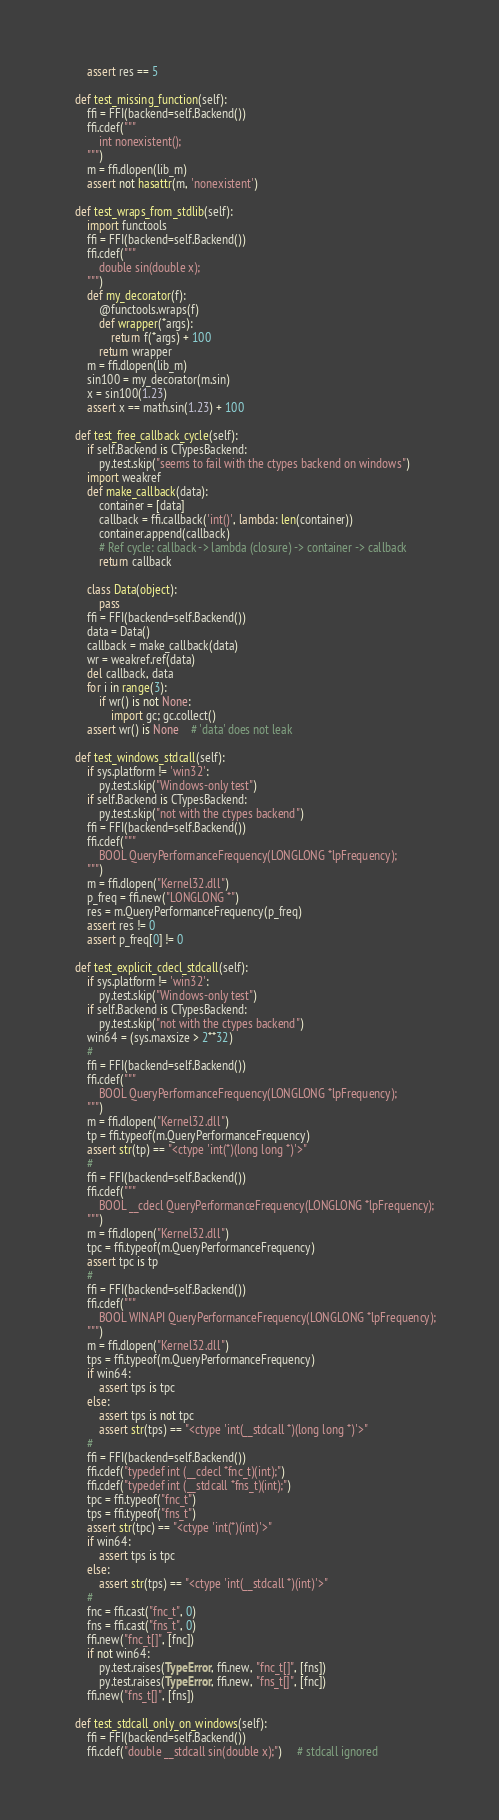<code> <loc_0><loc_0><loc_500><loc_500><_Python_>        assert res == 5

    def test_missing_function(self):
        ffi = FFI(backend=self.Backend())
        ffi.cdef("""
            int nonexistent();
        """)
        m = ffi.dlopen(lib_m)
        assert not hasattr(m, 'nonexistent')

    def test_wraps_from_stdlib(self):
        import functools
        ffi = FFI(backend=self.Backend())
        ffi.cdef("""
            double sin(double x);
        """)
        def my_decorator(f):
            @functools.wraps(f)
            def wrapper(*args):
                return f(*args) + 100
            return wrapper
        m = ffi.dlopen(lib_m)
        sin100 = my_decorator(m.sin)
        x = sin100(1.23)
        assert x == math.sin(1.23) + 100

    def test_free_callback_cycle(self):
        if self.Backend is CTypesBackend:
            py.test.skip("seems to fail with the ctypes backend on windows")
        import weakref
        def make_callback(data):
            container = [data]
            callback = ffi.callback('int()', lambda: len(container))
            container.append(callback)
            # Ref cycle: callback -> lambda (closure) -> container -> callback
            return callback

        class Data(object):
            pass
        ffi = FFI(backend=self.Backend())
        data = Data()
        callback = make_callback(data)
        wr = weakref.ref(data)
        del callback, data
        for i in range(3):
            if wr() is not None:
                import gc; gc.collect()
        assert wr() is None    # 'data' does not leak

    def test_windows_stdcall(self):
        if sys.platform != 'win32':
            py.test.skip("Windows-only test")
        if self.Backend is CTypesBackend:
            py.test.skip("not with the ctypes backend")
        ffi = FFI(backend=self.Backend())
        ffi.cdef("""
            BOOL QueryPerformanceFrequency(LONGLONG *lpFrequency);
        """)
        m = ffi.dlopen("Kernel32.dll")
        p_freq = ffi.new("LONGLONG *")
        res = m.QueryPerformanceFrequency(p_freq)
        assert res != 0
        assert p_freq[0] != 0

    def test_explicit_cdecl_stdcall(self):
        if sys.platform != 'win32':
            py.test.skip("Windows-only test")
        if self.Backend is CTypesBackend:
            py.test.skip("not with the ctypes backend")
        win64 = (sys.maxsize > 2**32)
        #
        ffi = FFI(backend=self.Backend())
        ffi.cdef("""
            BOOL QueryPerformanceFrequency(LONGLONG *lpFrequency);
        """)
        m = ffi.dlopen("Kernel32.dll")
        tp = ffi.typeof(m.QueryPerformanceFrequency)
        assert str(tp) == "<ctype 'int(*)(long long *)'>"
        #
        ffi = FFI(backend=self.Backend())
        ffi.cdef("""
            BOOL __cdecl QueryPerformanceFrequency(LONGLONG *lpFrequency);
        """)
        m = ffi.dlopen("Kernel32.dll")
        tpc = ffi.typeof(m.QueryPerformanceFrequency)
        assert tpc is tp
        #
        ffi = FFI(backend=self.Backend())
        ffi.cdef("""
            BOOL WINAPI QueryPerformanceFrequency(LONGLONG *lpFrequency);
        """)
        m = ffi.dlopen("Kernel32.dll")
        tps = ffi.typeof(m.QueryPerformanceFrequency)
        if win64:
            assert tps is tpc
        else:
            assert tps is not tpc
            assert str(tps) == "<ctype 'int(__stdcall *)(long long *)'>"
        #
        ffi = FFI(backend=self.Backend())
        ffi.cdef("typedef int (__cdecl *fnc_t)(int);")
        ffi.cdef("typedef int (__stdcall *fns_t)(int);")
        tpc = ffi.typeof("fnc_t")
        tps = ffi.typeof("fns_t")
        assert str(tpc) == "<ctype 'int(*)(int)'>"
        if win64:
            assert tps is tpc
        else:
            assert str(tps) == "<ctype 'int(__stdcall *)(int)'>"
        #
        fnc = ffi.cast("fnc_t", 0)
        fns = ffi.cast("fns_t", 0)
        ffi.new("fnc_t[]", [fnc])
        if not win64:
            py.test.raises(TypeError, ffi.new, "fnc_t[]", [fns])
            py.test.raises(TypeError, ffi.new, "fns_t[]", [fnc])
        ffi.new("fns_t[]", [fns])

    def test_stdcall_only_on_windows(self):
        ffi = FFI(backend=self.Backend())
        ffi.cdef("double __stdcall sin(double x);")     # stdcall ignored</code> 